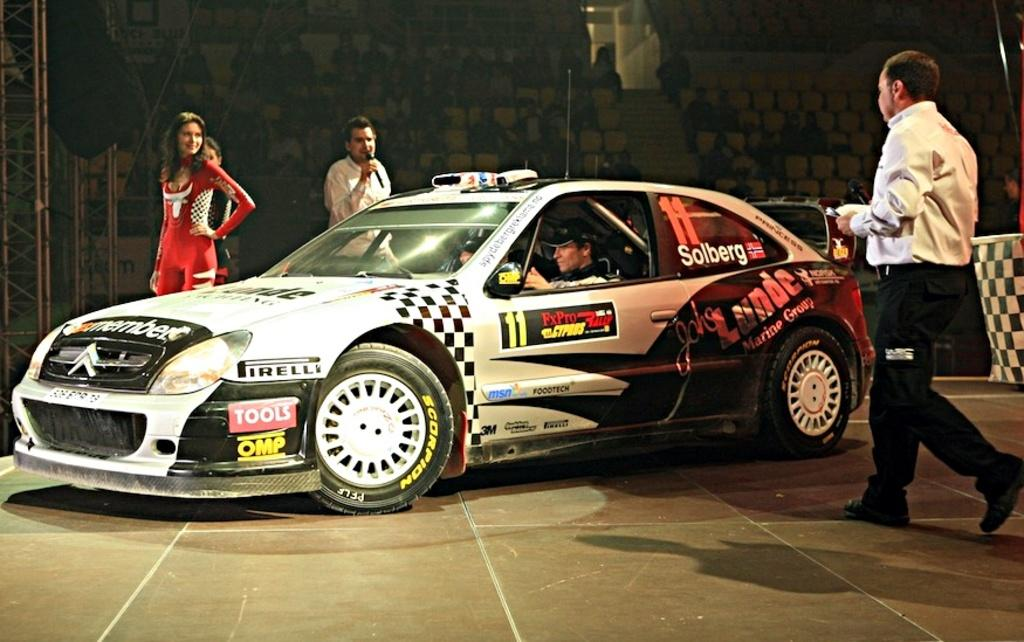What is the main subject in the middle of the image? There is a car in the middle of the image. What is the man doing on the right side of the image? The man is walking on the right side of the image. What is the woman doing on the left side of the image? The woman is standing on the left side of the image. What is the woman wearing? The woman is wearing a red color dress. What news is the cent delivering to the woman in the image? There is no cent present in the image, and therefore no news can be delivered. 